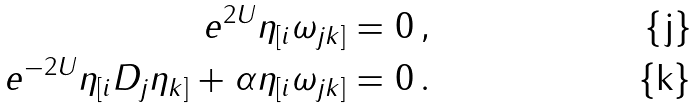Convert formula to latex. <formula><loc_0><loc_0><loc_500><loc_500>e ^ { 2 U } \eta _ { [ i } \omega _ { j k ] } & = 0 \, , \\ e ^ { - 2 U } \eta _ { [ i } D _ { j } \eta _ { k ] } + \alpha \eta _ { [ i } \omega _ { j k ] } & = 0 \, .</formula> 